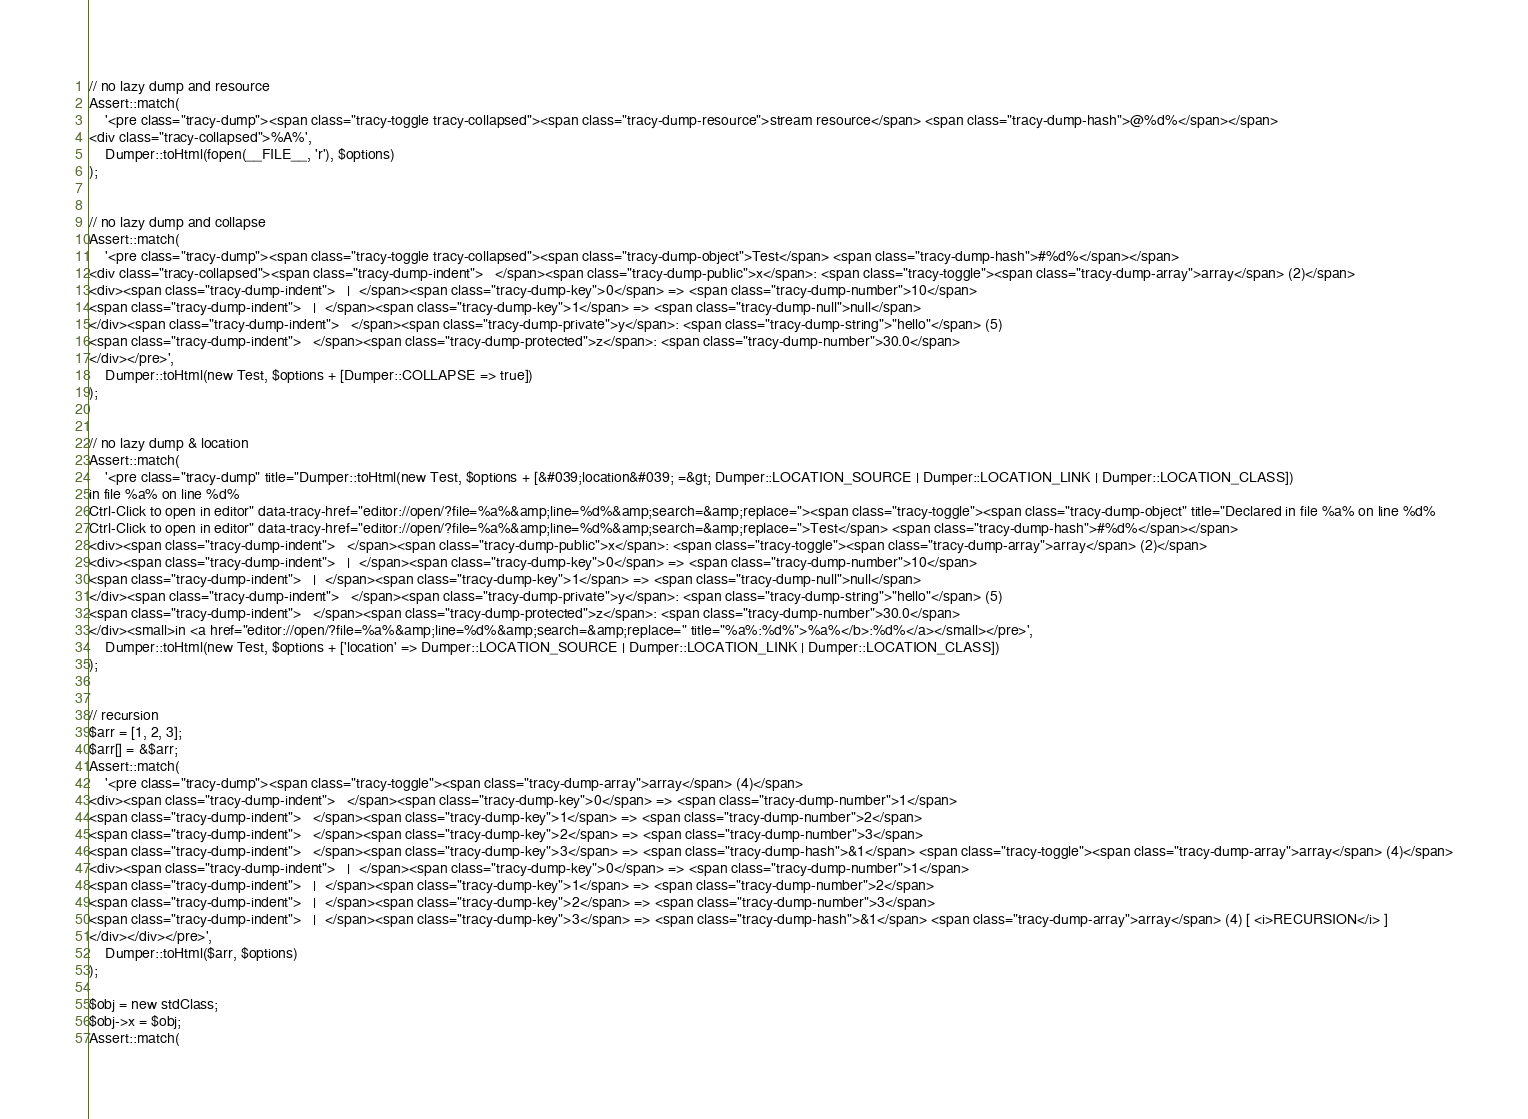Convert code to text. <code><loc_0><loc_0><loc_500><loc_500><_PHP_>// no lazy dump and resource
Assert::match(
	'<pre class="tracy-dump"><span class="tracy-toggle tracy-collapsed"><span class="tracy-dump-resource">stream resource</span> <span class="tracy-dump-hash">@%d%</span></span>
<div class="tracy-collapsed">%A%',
	Dumper::toHtml(fopen(__FILE__, 'r'), $options)
);


// no lazy dump and collapse
Assert::match(
	'<pre class="tracy-dump"><span class="tracy-toggle tracy-collapsed"><span class="tracy-dump-object">Test</span> <span class="tracy-dump-hash">#%d%</span></span>
<div class="tracy-collapsed"><span class="tracy-dump-indent">   </span><span class="tracy-dump-public">x</span>: <span class="tracy-toggle"><span class="tracy-dump-array">array</span> (2)</span>
<div><span class="tracy-dump-indent">   |  </span><span class="tracy-dump-key">0</span> => <span class="tracy-dump-number">10</span>
<span class="tracy-dump-indent">   |  </span><span class="tracy-dump-key">1</span> => <span class="tracy-dump-null">null</span>
</div><span class="tracy-dump-indent">   </span><span class="tracy-dump-private">y</span>: <span class="tracy-dump-string">"hello"</span> (5)
<span class="tracy-dump-indent">   </span><span class="tracy-dump-protected">z</span>: <span class="tracy-dump-number">30.0</span>
</div></pre>',
	Dumper::toHtml(new Test, $options + [Dumper::COLLAPSE => true])
);


// no lazy dump & location
Assert::match(
	'<pre class="tracy-dump" title="Dumper::toHtml(new Test, $options + [&#039;location&#039; =&gt; Dumper::LOCATION_SOURCE | Dumper::LOCATION_LINK | Dumper::LOCATION_CLASS])
in file %a% on line %d%
Ctrl-Click to open in editor" data-tracy-href="editor://open/?file=%a%&amp;line=%d%&amp;search=&amp;replace="><span class="tracy-toggle"><span class="tracy-dump-object" title="Declared in file %a% on line %d%
Ctrl-Click to open in editor" data-tracy-href="editor://open/?file=%a%&amp;line=%d%&amp;search=&amp;replace=">Test</span> <span class="tracy-dump-hash">#%d%</span></span>
<div><span class="tracy-dump-indent">   </span><span class="tracy-dump-public">x</span>: <span class="tracy-toggle"><span class="tracy-dump-array">array</span> (2)</span>
<div><span class="tracy-dump-indent">   |  </span><span class="tracy-dump-key">0</span> => <span class="tracy-dump-number">10</span>
<span class="tracy-dump-indent">   |  </span><span class="tracy-dump-key">1</span> => <span class="tracy-dump-null">null</span>
</div><span class="tracy-dump-indent">   </span><span class="tracy-dump-private">y</span>: <span class="tracy-dump-string">"hello"</span> (5)
<span class="tracy-dump-indent">   </span><span class="tracy-dump-protected">z</span>: <span class="tracy-dump-number">30.0</span>
</div><small>in <a href="editor://open/?file=%a%&amp;line=%d%&amp;search=&amp;replace=" title="%a%:%d%">%a%</b>:%d%</a></small></pre>',
	Dumper::toHtml(new Test, $options + ['location' => Dumper::LOCATION_SOURCE | Dumper::LOCATION_LINK | Dumper::LOCATION_CLASS])
);


// recursion
$arr = [1, 2, 3];
$arr[] = &$arr;
Assert::match(
	'<pre class="tracy-dump"><span class="tracy-toggle"><span class="tracy-dump-array">array</span> (4)</span>
<div><span class="tracy-dump-indent">   </span><span class="tracy-dump-key">0</span> => <span class="tracy-dump-number">1</span>
<span class="tracy-dump-indent">   </span><span class="tracy-dump-key">1</span> => <span class="tracy-dump-number">2</span>
<span class="tracy-dump-indent">   </span><span class="tracy-dump-key">2</span> => <span class="tracy-dump-number">3</span>
<span class="tracy-dump-indent">   </span><span class="tracy-dump-key">3</span> => <span class="tracy-dump-hash">&1</span> <span class="tracy-toggle"><span class="tracy-dump-array">array</span> (4)</span>
<div><span class="tracy-dump-indent">   |  </span><span class="tracy-dump-key">0</span> => <span class="tracy-dump-number">1</span>
<span class="tracy-dump-indent">   |  </span><span class="tracy-dump-key">1</span> => <span class="tracy-dump-number">2</span>
<span class="tracy-dump-indent">   |  </span><span class="tracy-dump-key">2</span> => <span class="tracy-dump-number">3</span>
<span class="tracy-dump-indent">   |  </span><span class="tracy-dump-key">3</span> => <span class="tracy-dump-hash">&1</span> <span class="tracy-dump-array">array</span> (4) [ <i>RECURSION</i> ]
</div></div></pre>',
	Dumper::toHtml($arr, $options)
);

$obj = new stdClass;
$obj->x = $obj;
Assert::match(</code> 